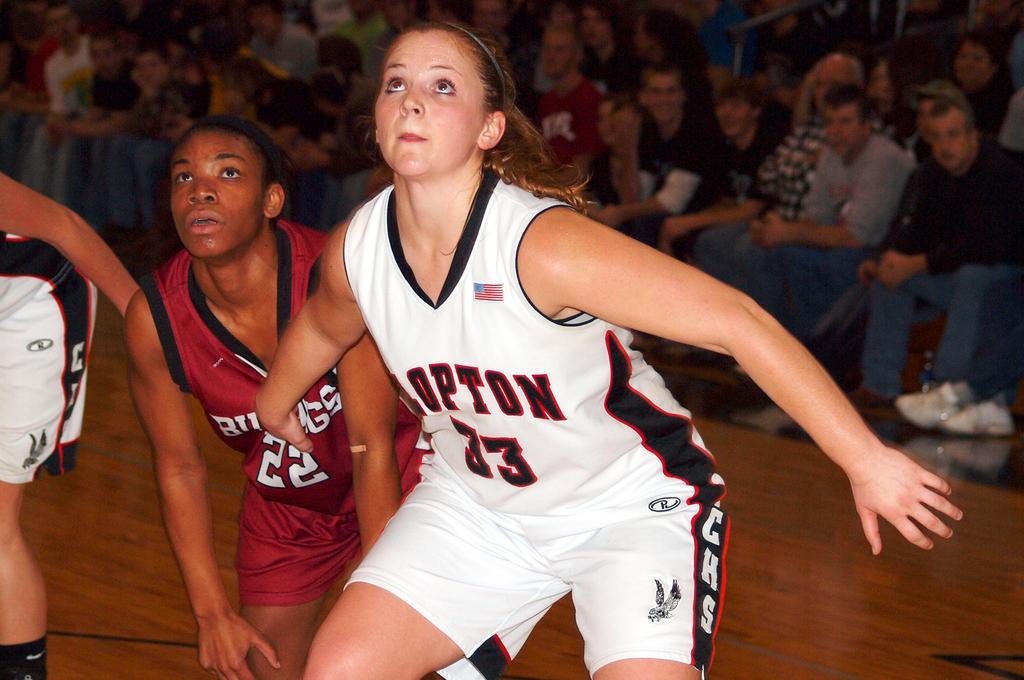What is the number on the red jersey?
Provide a short and direct response. 22. What is the number on the white jersey?
Your answer should be compact. 33. 